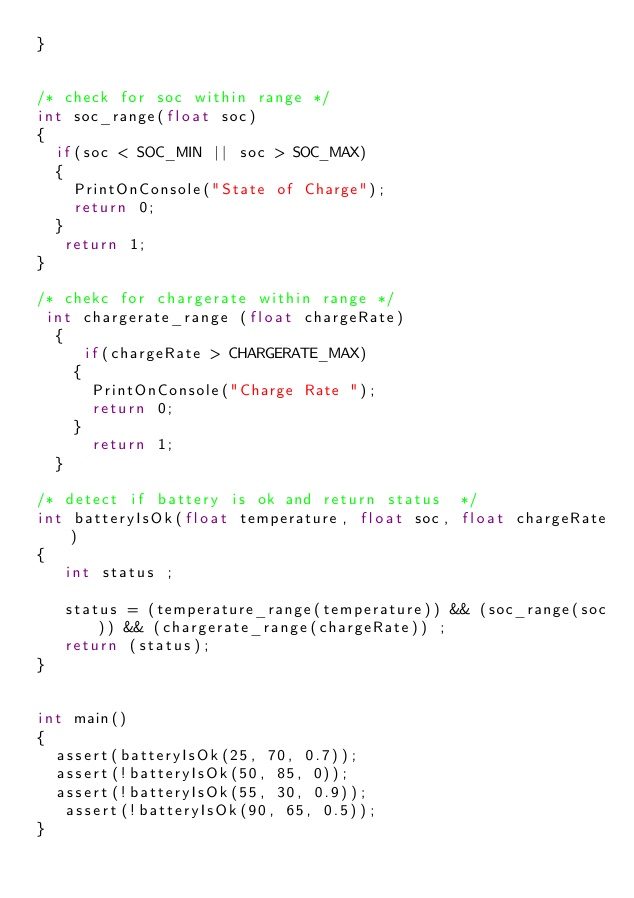<code> <loc_0><loc_0><loc_500><loc_500><_C_>}
  

/* check for soc within range */
int soc_range(float soc)
{
  if(soc < SOC_MIN || soc > SOC_MAX) 
  {
    PrintOnConsole("State of Charge");
    return 0;
  }
   return 1;
}
  
/* chekc for chargerate within range */
 int chargerate_range (float chargeRate)
  {
     if(chargeRate > CHARGERATE_MAX)
    {
      PrintOnConsole("Charge Rate ");
      return 0;
    }
      return 1;
  }

/* detect if battery is ok and return status  */
int batteryIsOk(float temperature, float soc, float chargeRate) 
{
   int status ;
    
   status = (temperature_range(temperature)) && (soc_range(soc)) && (chargerate_range(chargeRate)) ;
   return (status);
}
   

int main() 
{
  assert(batteryIsOk(25, 70, 0.7));
  assert(!batteryIsOk(50, 85, 0));
  assert(!batteryIsOk(55, 30, 0.9));
   assert(!batteryIsOk(90, 65, 0.5));
}
</code> 